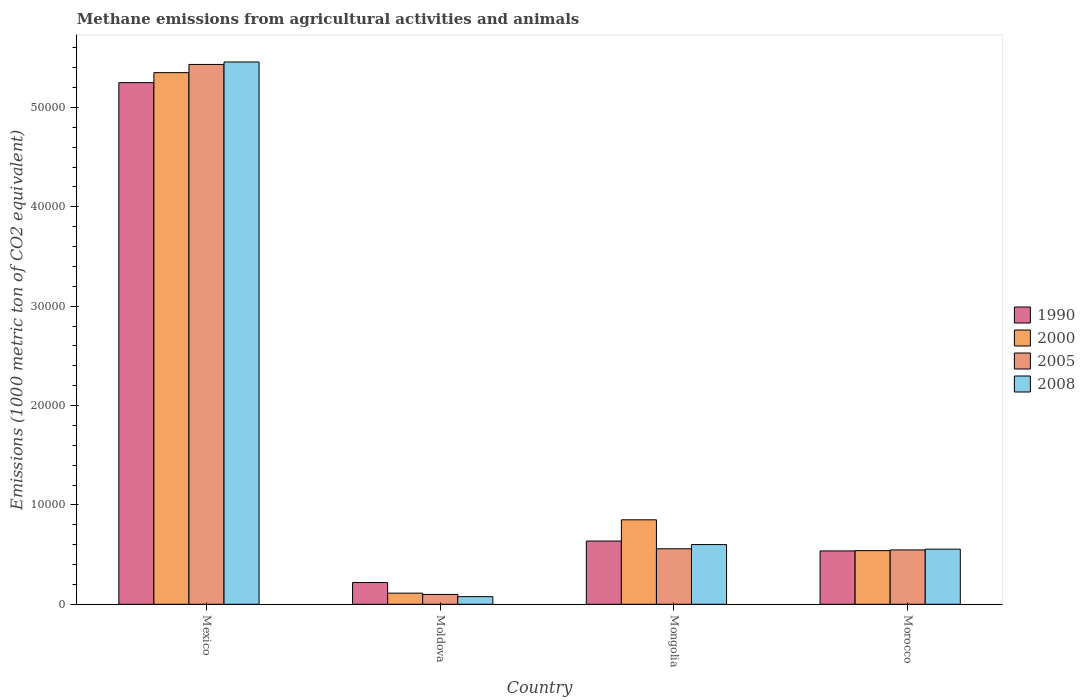How many different coloured bars are there?
Make the answer very short. 4. Are the number of bars per tick equal to the number of legend labels?
Provide a short and direct response. Yes. Are the number of bars on each tick of the X-axis equal?
Ensure brevity in your answer.  Yes. How many bars are there on the 4th tick from the left?
Provide a succinct answer. 4. How many bars are there on the 1st tick from the right?
Keep it short and to the point. 4. What is the label of the 4th group of bars from the left?
Provide a succinct answer. Morocco. In how many cases, is the number of bars for a given country not equal to the number of legend labels?
Your answer should be compact. 0. What is the amount of methane emitted in 1990 in Mexico?
Your answer should be compact. 5.25e+04. Across all countries, what is the maximum amount of methane emitted in 1990?
Your answer should be compact. 5.25e+04. Across all countries, what is the minimum amount of methane emitted in 1990?
Give a very brief answer. 2188.8. In which country was the amount of methane emitted in 2000 minimum?
Your response must be concise. Moldova. What is the total amount of methane emitted in 1990 in the graph?
Your answer should be compact. 6.64e+04. What is the difference between the amount of methane emitted in 1990 in Mexico and that in Morocco?
Your answer should be compact. 4.71e+04. What is the difference between the amount of methane emitted in 2005 in Mexico and the amount of methane emitted in 2008 in Moldova?
Offer a very short reply. 5.36e+04. What is the average amount of methane emitted in 2008 per country?
Your response must be concise. 1.67e+04. What is the difference between the amount of methane emitted of/in 1990 and amount of methane emitted of/in 2005 in Morocco?
Offer a very short reply. -102.6. In how many countries, is the amount of methane emitted in 2008 greater than 54000 1000 metric ton?
Give a very brief answer. 1. What is the ratio of the amount of methane emitted in 1990 in Mexico to that in Morocco?
Ensure brevity in your answer.  9.78. Is the difference between the amount of methane emitted in 1990 in Moldova and Morocco greater than the difference between the amount of methane emitted in 2005 in Moldova and Morocco?
Your answer should be very brief. Yes. What is the difference between the highest and the second highest amount of methane emitted in 2008?
Make the answer very short. 4.86e+04. What is the difference between the highest and the lowest amount of methane emitted in 2005?
Your answer should be compact. 5.33e+04. In how many countries, is the amount of methane emitted in 2008 greater than the average amount of methane emitted in 2008 taken over all countries?
Provide a succinct answer. 1. Is the sum of the amount of methane emitted in 2005 in Moldova and Mongolia greater than the maximum amount of methane emitted in 2008 across all countries?
Offer a terse response. No. Is it the case that in every country, the sum of the amount of methane emitted in 2000 and amount of methane emitted in 1990 is greater than the sum of amount of methane emitted in 2008 and amount of methane emitted in 2005?
Make the answer very short. No. What does the 1st bar from the left in Moldova represents?
Provide a short and direct response. 1990. What does the 3rd bar from the right in Morocco represents?
Give a very brief answer. 2000. How many bars are there?
Provide a succinct answer. 16. Are all the bars in the graph horizontal?
Ensure brevity in your answer.  No. How many countries are there in the graph?
Ensure brevity in your answer.  4. Are the values on the major ticks of Y-axis written in scientific E-notation?
Offer a very short reply. No. Does the graph contain grids?
Provide a succinct answer. No. How many legend labels are there?
Keep it short and to the point. 4. What is the title of the graph?
Offer a very short reply. Methane emissions from agricultural activities and animals. Does "1962" appear as one of the legend labels in the graph?
Make the answer very short. No. What is the label or title of the X-axis?
Provide a short and direct response. Country. What is the label or title of the Y-axis?
Make the answer very short. Emissions (1000 metric ton of CO2 equivalent). What is the Emissions (1000 metric ton of CO2 equivalent) of 1990 in Mexico?
Your answer should be compact. 5.25e+04. What is the Emissions (1000 metric ton of CO2 equivalent) in 2000 in Mexico?
Give a very brief answer. 5.35e+04. What is the Emissions (1000 metric ton of CO2 equivalent) in 2005 in Mexico?
Give a very brief answer. 5.43e+04. What is the Emissions (1000 metric ton of CO2 equivalent) in 2008 in Mexico?
Ensure brevity in your answer.  5.46e+04. What is the Emissions (1000 metric ton of CO2 equivalent) in 1990 in Moldova?
Provide a short and direct response. 2188.8. What is the Emissions (1000 metric ton of CO2 equivalent) in 2000 in Moldova?
Ensure brevity in your answer.  1119.3. What is the Emissions (1000 metric ton of CO2 equivalent) of 2005 in Moldova?
Ensure brevity in your answer.  990.3. What is the Emissions (1000 metric ton of CO2 equivalent) in 2008 in Moldova?
Give a very brief answer. 767.1. What is the Emissions (1000 metric ton of CO2 equivalent) of 1990 in Mongolia?
Provide a succinct answer. 6363.5. What is the Emissions (1000 metric ton of CO2 equivalent) in 2000 in Mongolia?
Give a very brief answer. 8502.3. What is the Emissions (1000 metric ton of CO2 equivalent) in 2005 in Mongolia?
Keep it short and to the point. 5584.9. What is the Emissions (1000 metric ton of CO2 equivalent) of 2008 in Mongolia?
Give a very brief answer. 6009.3. What is the Emissions (1000 metric ton of CO2 equivalent) of 1990 in Morocco?
Provide a succinct answer. 5368.8. What is the Emissions (1000 metric ton of CO2 equivalent) of 2000 in Morocco?
Your response must be concise. 5400.3. What is the Emissions (1000 metric ton of CO2 equivalent) in 2005 in Morocco?
Offer a terse response. 5471.4. What is the Emissions (1000 metric ton of CO2 equivalent) of 2008 in Morocco?
Keep it short and to the point. 5546.4. Across all countries, what is the maximum Emissions (1000 metric ton of CO2 equivalent) of 1990?
Your answer should be compact. 5.25e+04. Across all countries, what is the maximum Emissions (1000 metric ton of CO2 equivalent) of 2000?
Your answer should be very brief. 5.35e+04. Across all countries, what is the maximum Emissions (1000 metric ton of CO2 equivalent) of 2005?
Keep it short and to the point. 5.43e+04. Across all countries, what is the maximum Emissions (1000 metric ton of CO2 equivalent) of 2008?
Ensure brevity in your answer.  5.46e+04. Across all countries, what is the minimum Emissions (1000 metric ton of CO2 equivalent) in 1990?
Make the answer very short. 2188.8. Across all countries, what is the minimum Emissions (1000 metric ton of CO2 equivalent) of 2000?
Offer a very short reply. 1119.3. Across all countries, what is the minimum Emissions (1000 metric ton of CO2 equivalent) in 2005?
Your answer should be compact. 990.3. Across all countries, what is the minimum Emissions (1000 metric ton of CO2 equivalent) in 2008?
Your answer should be very brief. 767.1. What is the total Emissions (1000 metric ton of CO2 equivalent) in 1990 in the graph?
Offer a very short reply. 6.64e+04. What is the total Emissions (1000 metric ton of CO2 equivalent) in 2000 in the graph?
Keep it short and to the point. 6.85e+04. What is the total Emissions (1000 metric ton of CO2 equivalent) of 2005 in the graph?
Offer a terse response. 6.64e+04. What is the total Emissions (1000 metric ton of CO2 equivalent) of 2008 in the graph?
Your response must be concise. 6.69e+04. What is the difference between the Emissions (1000 metric ton of CO2 equivalent) in 1990 in Mexico and that in Moldova?
Offer a terse response. 5.03e+04. What is the difference between the Emissions (1000 metric ton of CO2 equivalent) in 2000 in Mexico and that in Moldova?
Offer a terse response. 5.24e+04. What is the difference between the Emissions (1000 metric ton of CO2 equivalent) of 2005 in Mexico and that in Moldova?
Your answer should be compact. 5.33e+04. What is the difference between the Emissions (1000 metric ton of CO2 equivalent) of 2008 in Mexico and that in Moldova?
Provide a succinct answer. 5.38e+04. What is the difference between the Emissions (1000 metric ton of CO2 equivalent) of 1990 in Mexico and that in Mongolia?
Your answer should be compact. 4.61e+04. What is the difference between the Emissions (1000 metric ton of CO2 equivalent) of 2000 in Mexico and that in Mongolia?
Give a very brief answer. 4.50e+04. What is the difference between the Emissions (1000 metric ton of CO2 equivalent) of 2005 in Mexico and that in Mongolia?
Your answer should be compact. 4.87e+04. What is the difference between the Emissions (1000 metric ton of CO2 equivalent) in 2008 in Mexico and that in Mongolia?
Offer a terse response. 4.86e+04. What is the difference between the Emissions (1000 metric ton of CO2 equivalent) of 1990 in Mexico and that in Morocco?
Keep it short and to the point. 4.71e+04. What is the difference between the Emissions (1000 metric ton of CO2 equivalent) in 2000 in Mexico and that in Morocco?
Provide a succinct answer. 4.81e+04. What is the difference between the Emissions (1000 metric ton of CO2 equivalent) in 2005 in Mexico and that in Morocco?
Give a very brief answer. 4.89e+04. What is the difference between the Emissions (1000 metric ton of CO2 equivalent) of 2008 in Mexico and that in Morocco?
Make the answer very short. 4.90e+04. What is the difference between the Emissions (1000 metric ton of CO2 equivalent) in 1990 in Moldova and that in Mongolia?
Provide a succinct answer. -4174.7. What is the difference between the Emissions (1000 metric ton of CO2 equivalent) in 2000 in Moldova and that in Mongolia?
Ensure brevity in your answer.  -7383. What is the difference between the Emissions (1000 metric ton of CO2 equivalent) in 2005 in Moldova and that in Mongolia?
Provide a short and direct response. -4594.6. What is the difference between the Emissions (1000 metric ton of CO2 equivalent) in 2008 in Moldova and that in Mongolia?
Your answer should be very brief. -5242.2. What is the difference between the Emissions (1000 metric ton of CO2 equivalent) in 1990 in Moldova and that in Morocco?
Keep it short and to the point. -3180. What is the difference between the Emissions (1000 metric ton of CO2 equivalent) in 2000 in Moldova and that in Morocco?
Keep it short and to the point. -4281. What is the difference between the Emissions (1000 metric ton of CO2 equivalent) in 2005 in Moldova and that in Morocco?
Your response must be concise. -4481.1. What is the difference between the Emissions (1000 metric ton of CO2 equivalent) in 2008 in Moldova and that in Morocco?
Your response must be concise. -4779.3. What is the difference between the Emissions (1000 metric ton of CO2 equivalent) of 1990 in Mongolia and that in Morocco?
Your response must be concise. 994.7. What is the difference between the Emissions (1000 metric ton of CO2 equivalent) of 2000 in Mongolia and that in Morocco?
Provide a succinct answer. 3102. What is the difference between the Emissions (1000 metric ton of CO2 equivalent) of 2005 in Mongolia and that in Morocco?
Your answer should be very brief. 113.5. What is the difference between the Emissions (1000 metric ton of CO2 equivalent) of 2008 in Mongolia and that in Morocco?
Provide a short and direct response. 462.9. What is the difference between the Emissions (1000 metric ton of CO2 equivalent) of 1990 in Mexico and the Emissions (1000 metric ton of CO2 equivalent) of 2000 in Moldova?
Your answer should be very brief. 5.14e+04. What is the difference between the Emissions (1000 metric ton of CO2 equivalent) in 1990 in Mexico and the Emissions (1000 metric ton of CO2 equivalent) in 2005 in Moldova?
Offer a terse response. 5.15e+04. What is the difference between the Emissions (1000 metric ton of CO2 equivalent) in 1990 in Mexico and the Emissions (1000 metric ton of CO2 equivalent) in 2008 in Moldova?
Ensure brevity in your answer.  5.17e+04. What is the difference between the Emissions (1000 metric ton of CO2 equivalent) of 2000 in Mexico and the Emissions (1000 metric ton of CO2 equivalent) of 2005 in Moldova?
Your answer should be compact. 5.25e+04. What is the difference between the Emissions (1000 metric ton of CO2 equivalent) in 2000 in Mexico and the Emissions (1000 metric ton of CO2 equivalent) in 2008 in Moldova?
Provide a short and direct response. 5.27e+04. What is the difference between the Emissions (1000 metric ton of CO2 equivalent) of 2005 in Mexico and the Emissions (1000 metric ton of CO2 equivalent) of 2008 in Moldova?
Keep it short and to the point. 5.36e+04. What is the difference between the Emissions (1000 metric ton of CO2 equivalent) of 1990 in Mexico and the Emissions (1000 metric ton of CO2 equivalent) of 2000 in Mongolia?
Give a very brief answer. 4.40e+04. What is the difference between the Emissions (1000 metric ton of CO2 equivalent) of 1990 in Mexico and the Emissions (1000 metric ton of CO2 equivalent) of 2005 in Mongolia?
Offer a very short reply. 4.69e+04. What is the difference between the Emissions (1000 metric ton of CO2 equivalent) in 1990 in Mexico and the Emissions (1000 metric ton of CO2 equivalent) in 2008 in Mongolia?
Offer a very short reply. 4.65e+04. What is the difference between the Emissions (1000 metric ton of CO2 equivalent) of 2000 in Mexico and the Emissions (1000 metric ton of CO2 equivalent) of 2005 in Mongolia?
Provide a succinct answer. 4.79e+04. What is the difference between the Emissions (1000 metric ton of CO2 equivalent) of 2000 in Mexico and the Emissions (1000 metric ton of CO2 equivalent) of 2008 in Mongolia?
Your answer should be very brief. 4.75e+04. What is the difference between the Emissions (1000 metric ton of CO2 equivalent) in 2005 in Mexico and the Emissions (1000 metric ton of CO2 equivalent) in 2008 in Mongolia?
Your answer should be compact. 4.83e+04. What is the difference between the Emissions (1000 metric ton of CO2 equivalent) in 1990 in Mexico and the Emissions (1000 metric ton of CO2 equivalent) in 2000 in Morocco?
Make the answer very short. 4.71e+04. What is the difference between the Emissions (1000 metric ton of CO2 equivalent) of 1990 in Mexico and the Emissions (1000 metric ton of CO2 equivalent) of 2005 in Morocco?
Make the answer very short. 4.70e+04. What is the difference between the Emissions (1000 metric ton of CO2 equivalent) of 1990 in Mexico and the Emissions (1000 metric ton of CO2 equivalent) of 2008 in Morocco?
Ensure brevity in your answer.  4.70e+04. What is the difference between the Emissions (1000 metric ton of CO2 equivalent) in 2000 in Mexico and the Emissions (1000 metric ton of CO2 equivalent) in 2005 in Morocco?
Your response must be concise. 4.80e+04. What is the difference between the Emissions (1000 metric ton of CO2 equivalent) of 2000 in Mexico and the Emissions (1000 metric ton of CO2 equivalent) of 2008 in Morocco?
Your response must be concise. 4.80e+04. What is the difference between the Emissions (1000 metric ton of CO2 equivalent) of 2005 in Mexico and the Emissions (1000 metric ton of CO2 equivalent) of 2008 in Morocco?
Ensure brevity in your answer.  4.88e+04. What is the difference between the Emissions (1000 metric ton of CO2 equivalent) in 1990 in Moldova and the Emissions (1000 metric ton of CO2 equivalent) in 2000 in Mongolia?
Ensure brevity in your answer.  -6313.5. What is the difference between the Emissions (1000 metric ton of CO2 equivalent) of 1990 in Moldova and the Emissions (1000 metric ton of CO2 equivalent) of 2005 in Mongolia?
Your answer should be very brief. -3396.1. What is the difference between the Emissions (1000 metric ton of CO2 equivalent) in 1990 in Moldova and the Emissions (1000 metric ton of CO2 equivalent) in 2008 in Mongolia?
Provide a short and direct response. -3820.5. What is the difference between the Emissions (1000 metric ton of CO2 equivalent) of 2000 in Moldova and the Emissions (1000 metric ton of CO2 equivalent) of 2005 in Mongolia?
Offer a very short reply. -4465.6. What is the difference between the Emissions (1000 metric ton of CO2 equivalent) of 2000 in Moldova and the Emissions (1000 metric ton of CO2 equivalent) of 2008 in Mongolia?
Your response must be concise. -4890. What is the difference between the Emissions (1000 metric ton of CO2 equivalent) of 2005 in Moldova and the Emissions (1000 metric ton of CO2 equivalent) of 2008 in Mongolia?
Keep it short and to the point. -5019. What is the difference between the Emissions (1000 metric ton of CO2 equivalent) of 1990 in Moldova and the Emissions (1000 metric ton of CO2 equivalent) of 2000 in Morocco?
Keep it short and to the point. -3211.5. What is the difference between the Emissions (1000 metric ton of CO2 equivalent) in 1990 in Moldova and the Emissions (1000 metric ton of CO2 equivalent) in 2005 in Morocco?
Your answer should be compact. -3282.6. What is the difference between the Emissions (1000 metric ton of CO2 equivalent) of 1990 in Moldova and the Emissions (1000 metric ton of CO2 equivalent) of 2008 in Morocco?
Ensure brevity in your answer.  -3357.6. What is the difference between the Emissions (1000 metric ton of CO2 equivalent) in 2000 in Moldova and the Emissions (1000 metric ton of CO2 equivalent) in 2005 in Morocco?
Keep it short and to the point. -4352.1. What is the difference between the Emissions (1000 metric ton of CO2 equivalent) in 2000 in Moldova and the Emissions (1000 metric ton of CO2 equivalent) in 2008 in Morocco?
Your response must be concise. -4427.1. What is the difference between the Emissions (1000 metric ton of CO2 equivalent) of 2005 in Moldova and the Emissions (1000 metric ton of CO2 equivalent) of 2008 in Morocco?
Your response must be concise. -4556.1. What is the difference between the Emissions (1000 metric ton of CO2 equivalent) of 1990 in Mongolia and the Emissions (1000 metric ton of CO2 equivalent) of 2000 in Morocco?
Give a very brief answer. 963.2. What is the difference between the Emissions (1000 metric ton of CO2 equivalent) of 1990 in Mongolia and the Emissions (1000 metric ton of CO2 equivalent) of 2005 in Morocco?
Ensure brevity in your answer.  892.1. What is the difference between the Emissions (1000 metric ton of CO2 equivalent) in 1990 in Mongolia and the Emissions (1000 metric ton of CO2 equivalent) in 2008 in Morocco?
Provide a short and direct response. 817.1. What is the difference between the Emissions (1000 metric ton of CO2 equivalent) of 2000 in Mongolia and the Emissions (1000 metric ton of CO2 equivalent) of 2005 in Morocco?
Make the answer very short. 3030.9. What is the difference between the Emissions (1000 metric ton of CO2 equivalent) of 2000 in Mongolia and the Emissions (1000 metric ton of CO2 equivalent) of 2008 in Morocco?
Keep it short and to the point. 2955.9. What is the difference between the Emissions (1000 metric ton of CO2 equivalent) of 2005 in Mongolia and the Emissions (1000 metric ton of CO2 equivalent) of 2008 in Morocco?
Offer a terse response. 38.5. What is the average Emissions (1000 metric ton of CO2 equivalent) of 1990 per country?
Your answer should be very brief. 1.66e+04. What is the average Emissions (1000 metric ton of CO2 equivalent) of 2000 per country?
Offer a very short reply. 1.71e+04. What is the average Emissions (1000 metric ton of CO2 equivalent) in 2005 per country?
Your response must be concise. 1.66e+04. What is the average Emissions (1000 metric ton of CO2 equivalent) in 2008 per country?
Provide a succinct answer. 1.67e+04. What is the difference between the Emissions (1000 metric ton of CO2 equivalent) in 1990 and Emissions (1000 metric ton of CO2 equivalent) in 2000 in Mexico?
Offer a terse response. -1007.1. What is the difference between the Emissions (1000 metric ton of CO2 equivalent) of 1990 and Emissions (1000 metric ton of CO2 equivalent) of 2005 in Mexico?
Provide a succinct answer. -1831.1. What is the difference between the Emissions (1000 metric ton of CO2 equivalent) in 1990 and Emissions (1000 metric ton of CO2 equivalent) in 2008 in Mexico?
Ensure brevity in your answer.  -2077.8. What is the difference between the Emissions (1000 metric ton of CO2 equivalent) of 2000 and Emissions (1000 metric ton of CO2 equivalent) of 2005 in Mexico?
Provide a short and direct response. -824. What is the difference between the Emissions (1000 metric ton of CO2 equivalent) in 2000 and Emissions (1000 metric ton of CO2 equivalent) in 2008 in Mexico?
Keep it short and to the point. -1070.7. What is the difference between the Emissions (1000 metric ton of CO2 equivalent) of 2005 and Emissions (1000 metric ton of CO2 equivalent) of 2008 in Mexico?
Your response must be concise. -246.7. What is the difference between the Emissions (1000 metric ton of CO2 equivalent) in 1990 and Emissions (1000 metric ton of CO2 equivalent) in 2000 in Moldova?
Your answer should be compact. 1069.5. What is the difference between the Emissions (1000 metric ton of CO2 equivalent) of 1990 and Emissions (1000 metric ton of CO2 equivalent) of 2005 in Moldova?
Provide a short and direct response. 1198.5. What is the difference between the Emissions (1000 metric ton of CO2 equivalent) in 1990 and Emissions (1000 metric ton of CO2 equivalent) in 2008 in Moldova?
Your response must be concise. 1421.7. What is the difference between the Emissions (1000 metric ton of CO2 equivalent) in 2000 and Emissions (1000 metric ton of CO2 equivalent) in 2005 in Moldova?
Keep it short and to the point. 129. What is the difference between the Emissions (1000 metric ton of CO2 equivalent) in 2000 and Emissions (1000 metric ton of CO2 equivalent) in 2008 in Moldova?
Offer a very short reply. 352.2. What is the difference between the Emissions (1000 metric ton of CO2 equivalent) in 2005 and Emissions (1000 metric ton of CO2 equivalent) in 2008 in Moldova?
Offer a terse response. 223.2. What is the difference between the Emissions (1000 metric ton of CO2 equivalent) of 1990 and Emissions (1000 metric ton of CO2 equivalent) of 2000 in Mongolia?
Offer a terse response. -2138.8. What is the difference between the Emissions (1000 metric ton of CO2 equivalent) of 1990 and Emissions (1000 metric ton of CO2 equivalent) of 2005 in Mongolia?
Your answer should be compact. 778.6. What is the difference between the Emissions (1000 metric ton of CO2 equivalent) of 1990 and Emissions (1000 metric ton of CO2 equivalent) of 2008 in Mongolia?
Make the answer very short. 354.2. What is the difference between the Emissions (1000 metric ton of CO2 equivalent) of 2000 and Emissions (1000 metric ton of CO2 equivalent) of 2005 in Mongolia?
Provide a short and direct response. 2917.4. What is the difference between the Emissions (1000 metric ton of CO2 equivalent) in 2000 and Emissions (1000 metric ton of CO2 equivalent) in 2008 in Mongolia?
Your response must be concise. 2493. What is the difference between the Emissions (1000 metric ton of CO2 equivalent) in 2005 and Emissions (1000 metric ton of CO2 equivalent) in 2008 in Mongolia?
Give a very brief answer. -424.4. What is the difference between the Emissions (1000 metric ton of CO2 equivalent) of 1990 and Emissions (1000 metric ton of CO2 equivalent) of 2000 in Morocco?
Offer a terse response. -31.5. What is the difference between the Emissions (1000 metric ton of CO2 equivalent) of 1990 and Emissions (1000 metric ton of CO2 equivalent) of 2005 in Morocco?
Provide a short and direct response. -102.6. What is the difference between the Emissions (1000 metric ton of CO2 equivalent) in 1990 and Emissions (1000 metric ton of CO2 equivalent) in 2008 in Morocco?
Offer a very short reply. -177.6. What is the difference between the Emissions (1000 metric ton of CO2 equivalent) of 2000 and Emissions (1000 metric ton of CO2 equivalent) of 2005 in Morocco?
Offer a terse response. -71.1. What is the difference between the Emissions (1000 metric ton of CO2 equivalent) of 2000 and Emissions (1000 metric ton of CO2 equivalent) of 2008 in Morocco?
Provide a short and direct response. -146.1. What is the difference between the Emissions (1000 metric ton of CO2 equivalent) of 2005 and Emissions (1000 metric ton of CO2 equivalent) of 2008 in Morocco?
Offer a very short reply. -75. What is the ratio of the Emissions (1000 metric ton of CO2 equivalent) in 1990 in Mexico to that in Moldova?
Give a very brief answer. 23.99. What is the ratio of the Emissions (1000 metric ton of CO2 equivalent) in 2000 in Mexico to that in Moldova?
Your answer should be very brief. 47.8. What is the ratio of the Emissions (1000 metric ton of CO2 equivalent) in 2005 in Mexico to that in Moldova?
Give a very brief answer. 54.86. What is the ratio of the Emissions (1000 metric ton of CO2 equivalent) in 2008 in Mexico to that in Moldova?
Offer a very short reply. 71.15. What is the ratio of the Emissions (1000 metric ton of CO2 equivalent) in 1990 in Mexico to that in Mongolia?
Make the answer very short. 8.25. What is the ratio of the Emissions (1000 metric ton of CO2 equivalent) of 2000 in Mexico to that in Mongolia?
Your answer should be compact. 6.29. What is the ratio of the Emissions (1000 metric ton of CO2 equivalent) in 2005 in Mexico to that in Mongolia?
Offer a very short reply. 9.73. What is the ratio of the Emissions (1000 metric ton of CO2 equivalent) of 2008 in Mexico to that in Mongolia?
Keep it short and to the point. 9.08. What is the ratio of the Emissions (1000 metric ton of CO2 equivalent) of 1990 in Mexico to that in Morocco?
Your response must be concise. 9.78. What is the ratio of the Emissions (1000 metric ton of CO2 equivalent) in 2000 in Mexico to that in Morocco?
Your response must be concise. 9.91. What is the ratio of the Emissions (1000 metric ton of CO2 equivalent) of 2005 in Mexico to that in Morocco?
Give a very brief answer. 9.93. What is the ratio of the Emissions (1000 metric ton of CO2 equivalent) of 2008 in Mexico to that in Morocco?
Your response must be concise. 9.84. What is the ratio of the Emissions (1000 metric ton of CO2 equivalent) of 1990 in Moldova to that in Mongolia?
Offer a terse response. 0.34. What is the ratio of the Emissions (1000 metric ton of CO2 equivalent) in 2000 in Moldova to that in Mongolia?
Ensure brevity in your answer.  0.13. What is the ratio of the Emissions (1000 metric ton of CO2 equivalent) in 2005 in Moldova to that in Mongolia?
Make the answer very short. 0.18. What is the ratio of the Emissions (1000 metric ton of CO2 equivalent) of 2008 in Moldova to that in Mongolia?
Your response must be concise. 0.13. What is the ratio of the Emissions (1000 metric ton of CO2 equivalent) of 1990 in Moldova to that in Morocco?
Make the answer very short. 0.41. What is the ratio of the Emissions (1000 metric ton of CO2 equivalent) in 2000 in Moldova to that in Morocco?
Provide a succinct answer. 0.21. What is the ratio of the Emissions (1000 metric ton of CO2 equivalent) of 2005 in Moldova to that in Morocco?
Make the answer very short. 0.18. What is the ratio of the Emissions (1000 metric ton of CO2 equivalent) in 2008 in Moldova to that in Morocco?
Your answer should be compact. 0.14. What is the ratio of the Emissions (1000 metric ton of CO2 equivalent) in 1990 in Mongolia to that in Morocco?
Your response must be concise. 1.19. What is the ratio of the Emissions (1000 metric ton of CO2 equivalent) of 2000 in Mongolia to that in Morocco?
Your answer should be very brief. 1.57. What is the ratio of the Emissions (1000 metric ton of CO2 equivalent) in 2005 in Mongolia to that in Morocco?
Your answer should be compact. 1.02. What is the ratio of the Emissions (1000 metric ton of CO2 equivalent) in 2008 in Mongolia to that in Morocco?
Offer a very short reply. 1.08. What is the difference between the highest and the second highest Emissions (1000 metric ton of CO2 equivalent) of 1990?
Your answer should be compact. 4.61e+04. What is the difference between the highest and the second highest Emissions (1000 metric ton of CO2 equivalent) in 2000?
Offer a very short reply. 4.50e+04. What is the difference between the highest and the second highest Emissions (1000 metric ton of CO2 equivalent) in 2005?
Provide a short and direct response. 4.87e+04. What is the difference between the highest and the second highest Emissions (1000 metric ton of CO2 equivalent) in 2008?
Make the answer very short. 4.86e+04. What is the difference between the highest and the lowest Emissions (1000 metric ton of CO2 equivalent) of 1990?
Give a very brief answer. 5.03e+04. What is the difference between the highest and the lowest Emissions (1000 metric ton of CO2 equivalent) of 2000?
Give a very brief answer. 5.24e+04. What is the difference between the highest and the lowest Emissions (1000 metric ton of CO2 equivalent) in 2005?
Ensure brevity in your answer.  5.33e+04. What is the difference between the highest and the lowest Emissions (1000 metric ton of CO2 equivalent) in 2008?
Your answer should be very brief. 5.38e+04. 